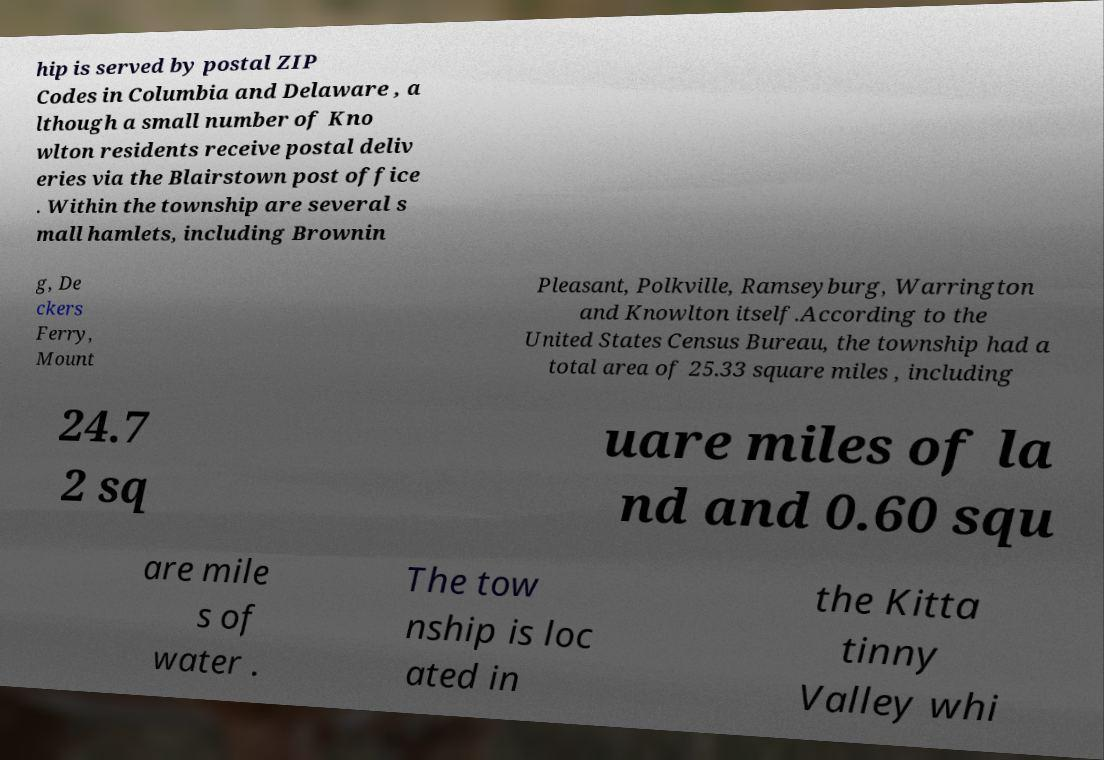Can you accurately transcribe the text from the provided image for me? hip is served by postal ZIP Codes in Columbia and Delaware , a lthough a small number of Kno wlton residents receive postal deliv eries via the Blairstown post office . Within the township are several s mall hamlets, including Brownin g, De ckers Ferry, Mount Pleasant, Polkville, Ramseyburg, Warrington and Knowlton itself.According to the United States Census Bureau, the township had a total area of 25.33 square miles , including 24.7 2 sq uare miles of la nd and 0.60 squ are mile s of water . The tow nship is loc ated in the Kitta tinny Valley whi 